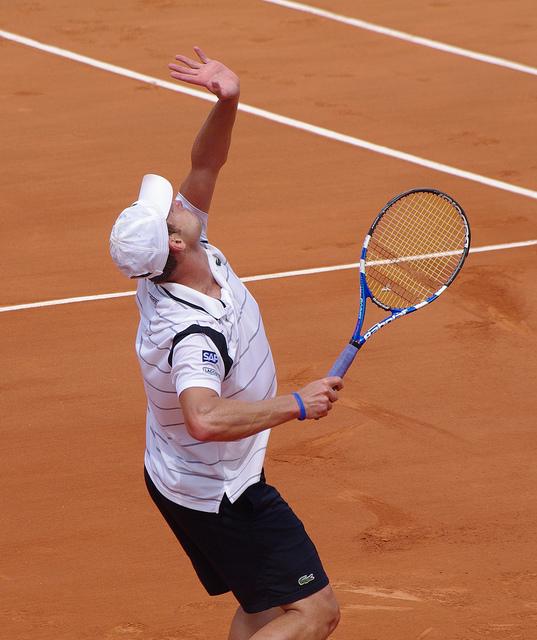Did he actually hit the ball?
Answer briefly. No. Why is the man's hand up in the air?
Be succinct. Serving. What color is the racket?
Short answer required. Blue. 